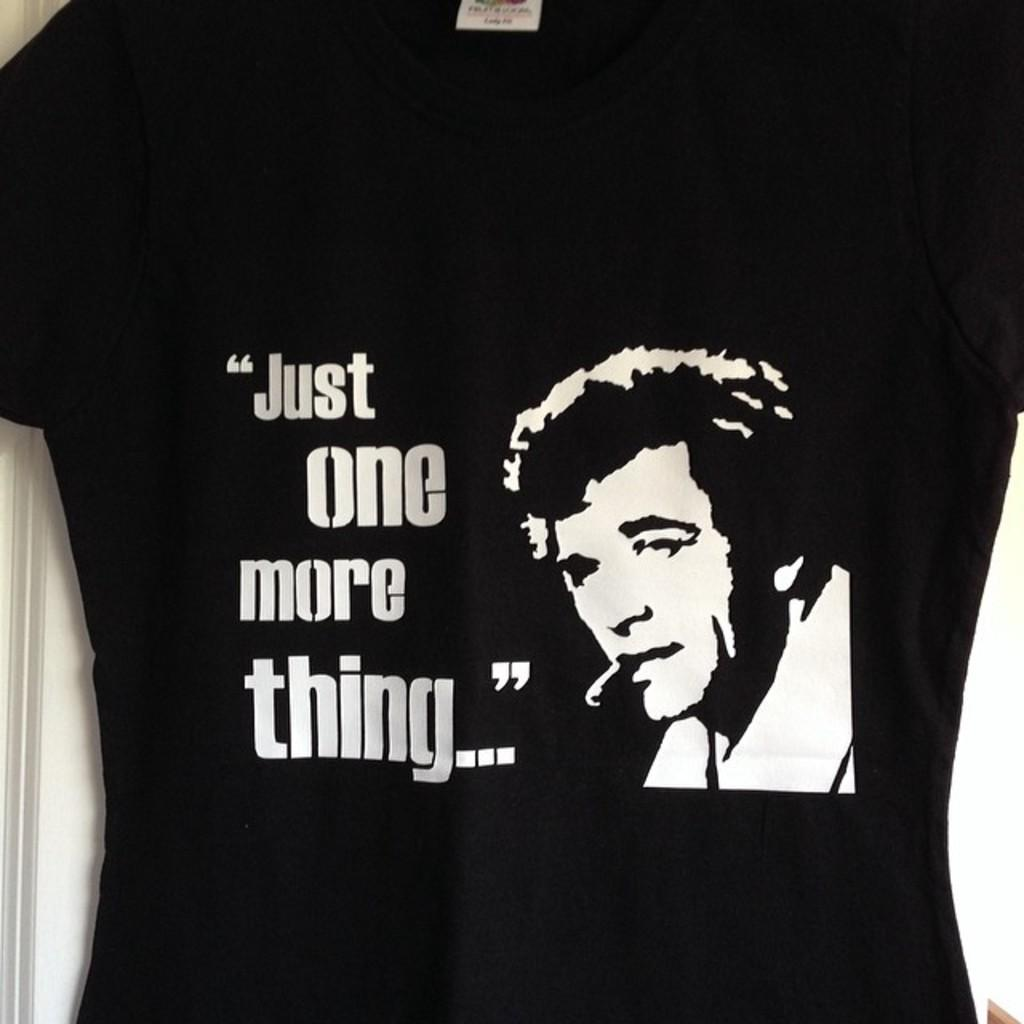What type of clothing is visible in the image? There is a black shirt in the image. Can you describe the person in the image? There is a person in the image. What is written on the shirt? There is matter written on the shirt. What color is the sun in the image? There is no sun present in the image. Are there any stockings visible on the person in the image? The provided facts do not mention stockings, so we cannot determine if they are visible or not. Is there a balloon in the image? The provided facts do not mention a balloon, so we cannot determine if it is present or not. 